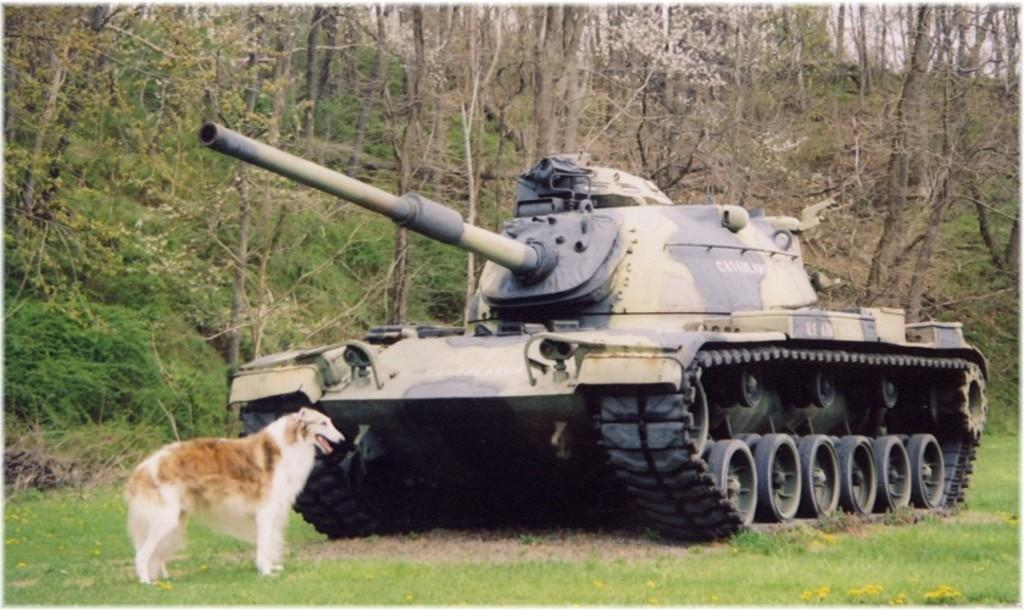What is the main object on the ground in the image? There is a tank on the ground in the image. What animal is in front of the tank? There is a dog in front of the tank. What can be seen in the distance behind the tank? There are trees visible in the background of the image. Where is the servant standing in relation to the tank in the image? There is no servant present in the image. What type of plants can be seen growing near the tank in the image? The provided facts do not mention any plants near the tank; only trees are mentioned in the background. 